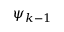Convert formula to latex. <formula><loc_0><loc_0><loc_500><loc_500>\psi _ { k - 1 }</formula> 